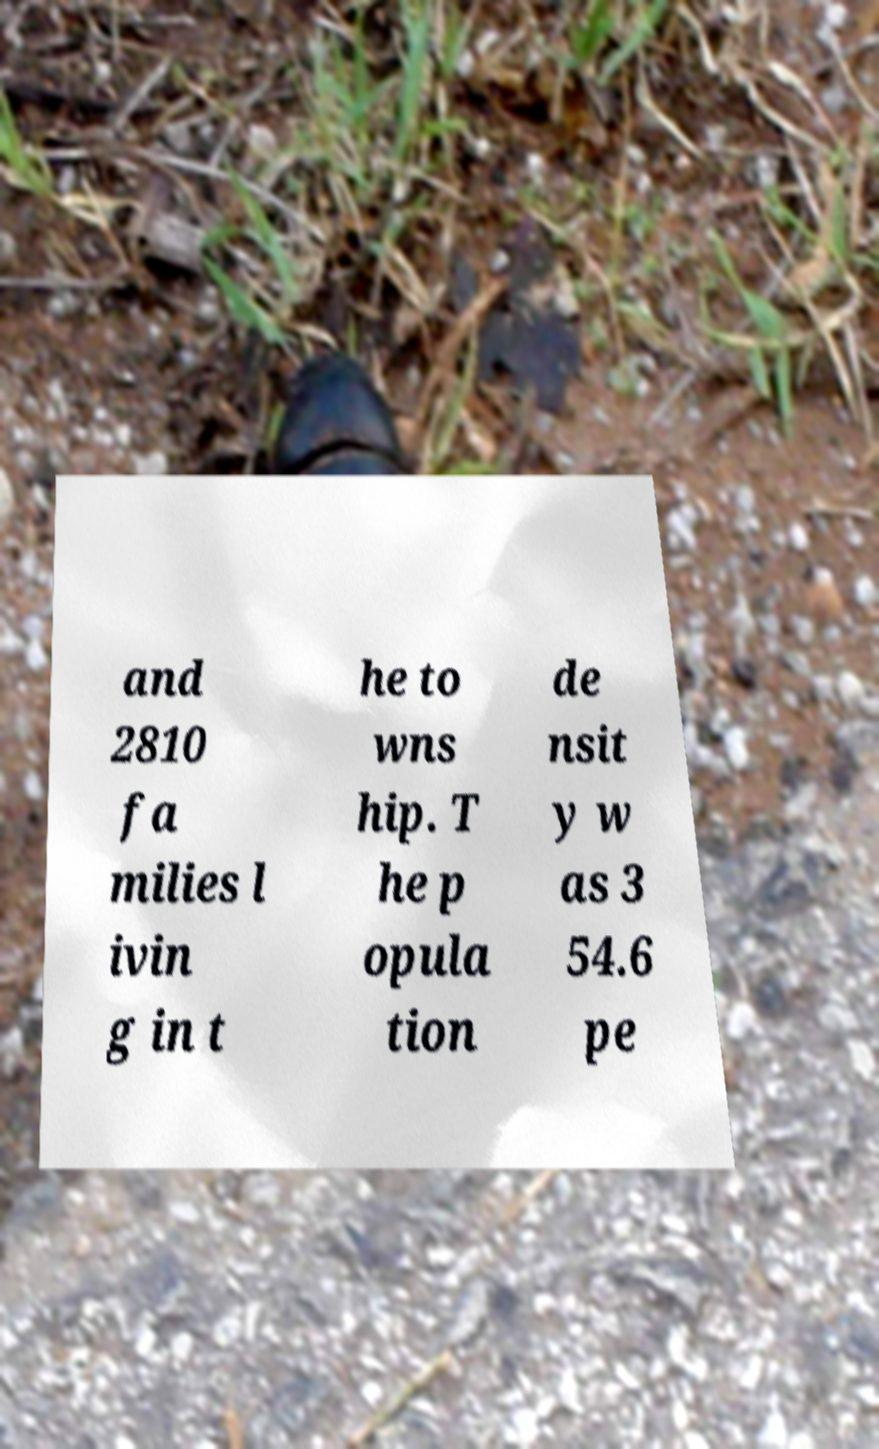I need the written content from this picture converted into text. Can you do that? and 2810 fa milies l ivin g in t he to wns hip. T he p opula tion de nsit y w as 3 54.6 pe 